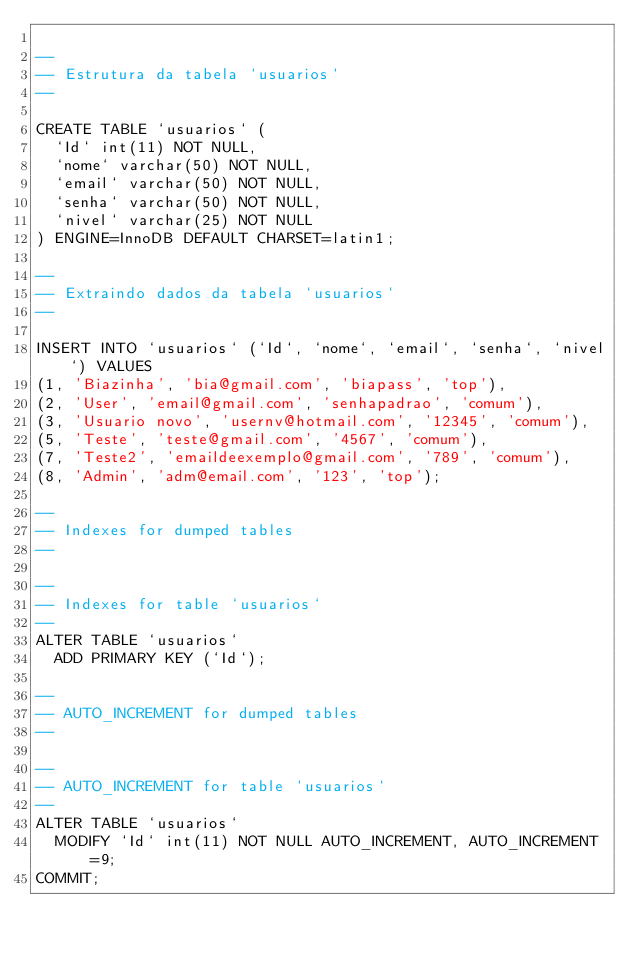<code> <loc_0><loc_0><loc_500><loc_500><_SQL_>
--
-- Estrutura da tabela `usuarios`
--

CREATE TABLE `usuarios` (
  `Id` int(11) NOT NULL,
  `nome` varchar(50) NOT NULL,
  `email` varchar(50) NOT NULL,
  `senha` varchar(50) NOT NULL,
  `nivel` varchar(25) NOT NULL
) ENGINE=InnoDB DEFAULT CHARSET=latin1;

--
-- Extraindo dados da tabela `usuarios`
--

INSERT INTO `usuarios` (`Id`, `nome`, `email`, `senha`, `nivel`) VALUES
(1, 'Biazinha', 'bia@gmail.com', 'biapass', 'top'),
(2, 'User', 'email@gmail.com', 'senhapadrao', 'comum'),
(3, 'Usuario novo', 'usernv@hotmail.com', '12345', 'comum'),
(5, 'Teste', 'teste@gmail.com', '4567', 'comum'),
(7, 'Teste2', 'emaildeexemplo@gmail.com', '789', 'comum'),
(8, 'Admin', 'adm@email.com', '123', 'top');

--
-- Indexes for dumped tables
--

--
-- Indexes for table `usuarios`
--
ALTER TABLE `usuarios`
  ADD PRIMARY KEY (`Id`);

--
-- AUTO_INCREMENT for dumped tables
--

--
-- AUTO_INCREMENT for table `usuarios`
--
ALTER TABLE `usuarios`
  MODIFY `Id` int(11) NOT NULL AUTO_INCREMENT, AUTO_INCREMENT=9;
COMMIT;
</code> 